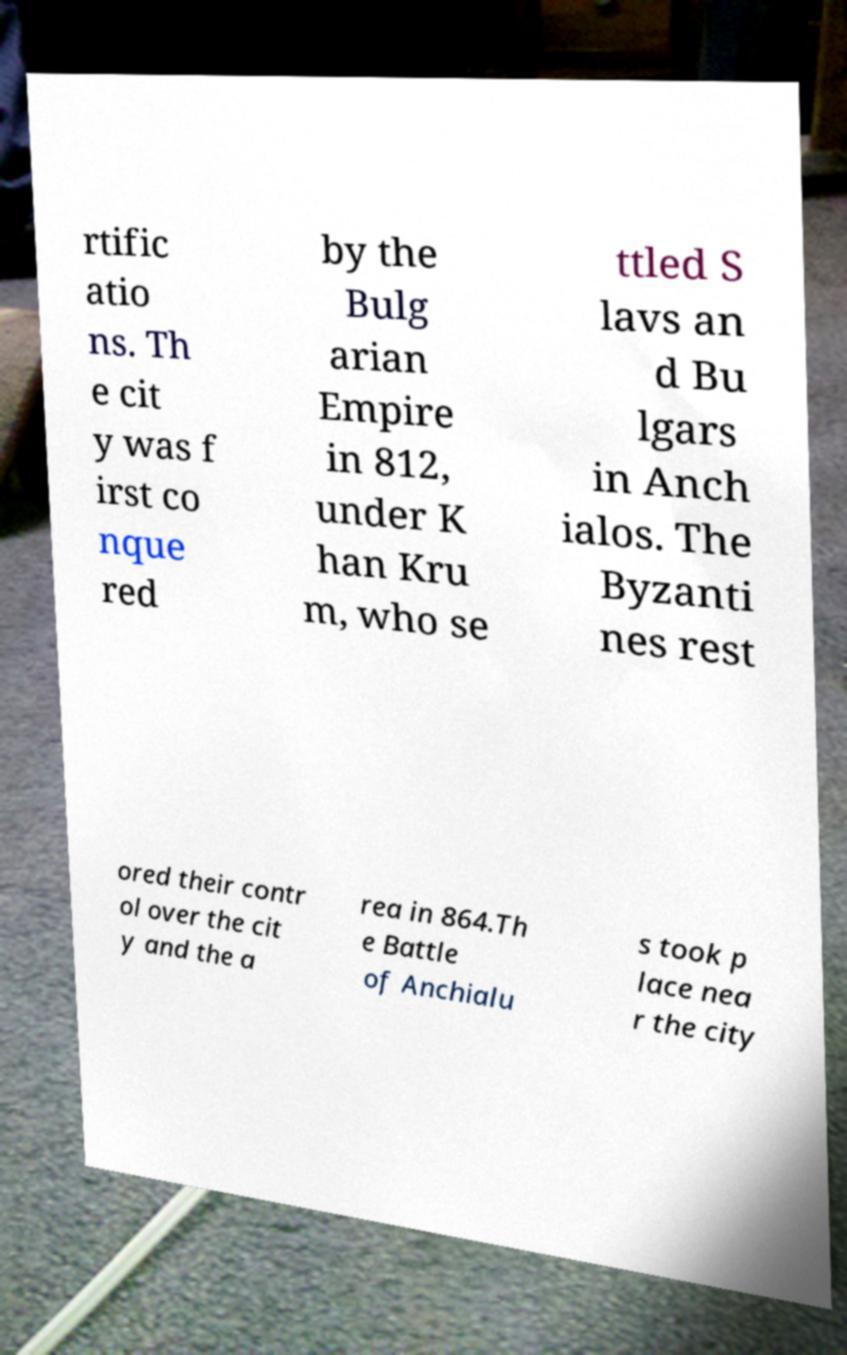Please read and relay the text visible in this image. What does it say? rtific atio ns. Th e cit y was f irst co nque red by the Bulg arian Empire in 812, under K han Kru m, who se ttled S lavs an d Bu lgars in Anch ialos. The Byzanti nes rest ored their contr ol over the cit y and the a rea in 864.Th e Battle of Anchialu s took p lace nea r the city 